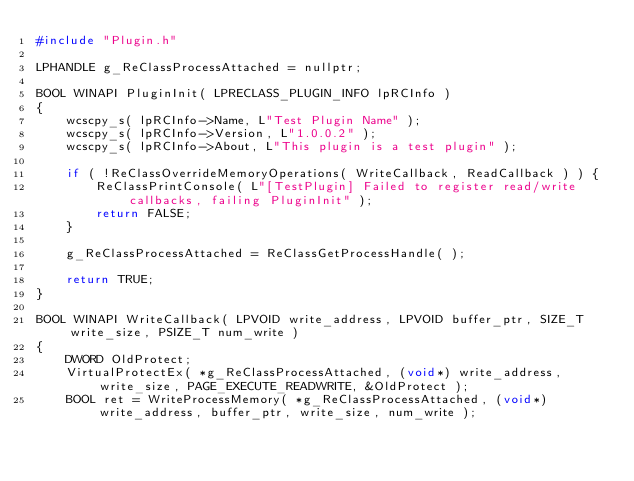<code> <loc_0><loc_0><loc_500><loc_500><_C++_>#include "Plugin.h"

LPHANDLE g_ReClassProcessAttached = nullptr;

BOOL WINAPI PluginInit( LPRECLASS_PLUGIN_INFO lpRCInfo )
{
	wcscpy_s( lpRCInfo->Name, L"Test Plugin Name" );
	wcscpy_s( lpRCInfo->Version, L"1.0.0.2" );
	wcscpy_s( lpRCInfo->About, L"This plugin is a test plugin" );

	if ( !ReClassOverrideMemoryOperations( WriteCallback, ReadCallback ) ) {
		ReClassPrintConsole( L"[TestPlugin] Failed to register read/write callbacks, failing PluginInit" );
		return FALSE;
	}

	g_ReClassProcessAttached = ReClassGetProcessHandle( );

	return TRUE;
}

BOOL WINAPI WriteCallback( LPVOID write_address, LPVOID buffer_ptr, SIZE_T write_size, PSIZE_T num_write )
{
	DWORD OldProtect;
	VirtualProtectEx( *g_ReClassProcessAttached, (void*) write_address, write_size, PAGE_EXECUTE_READWRITE, &OldProtect );
	BOOL ret = WriteProcessMemory( *g_ReClassProcessAttached, (void*) write_address, buffer_ptr, write_size, num_write );</code> 